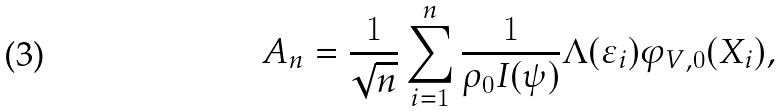<formula> <loc_0><loc_0><loc_500><loc_500>A _ { n } = \frac { 1 } { \sqrt { n } } \sum _ { i = 1 } ^ { n } \frac { 1 } { \rho _ { 0 } I ( \psi ) } \Lambda ( \varepsilon _ { i } ) \varphi _ { V , 0 } ( X _ { i } ) ,</formula> 